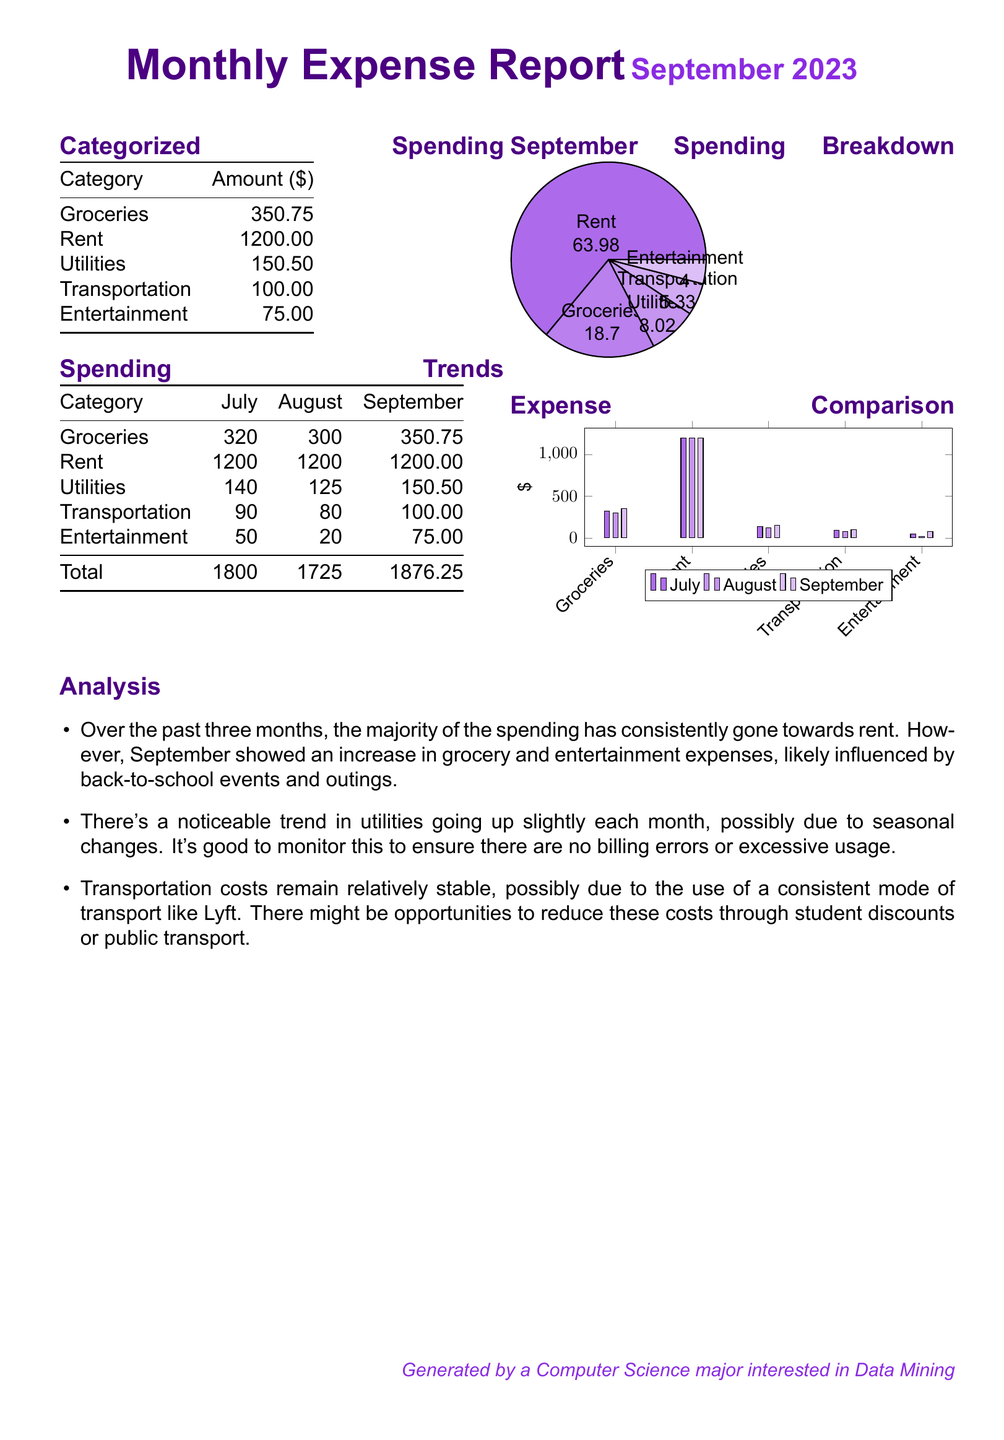What is the total amount spent in September? The total amount spent in September is found in the spending trends section, where the total is listed as $1876.25.
Answer: $1876.25 What category has the highest expenditure in September? The highest expenditure category in September is identified in the categorized spending section, where rent is shown to be $1200.00.
Answer: Rent What was the utilities expense in August? The utilities expense for August is found in the spending trends table, which shows $125.
Answer: $125 By how much did entertainment expenses increase from August to September? To find the increase, subtract the August entertainment expense ($20) from the September amount ($75), resulting in an increase of $55.
Answer: $55 What percentage of total spending in September is allocated to groceries? The spending breakdown shows groceries amounting to $350.75, which is calculated as (350.75 / 1876.25) * 100, resulting in approximately 18.7%.
Answer: 18.7% Which category showed an increase in expense every month from July to September? Examining the spending trends, utilities is the only category that shows a consistent increase from $140 in July to $150.50 in September.
Answer: Utilities What is the total amount spent on entertainment over the three months? The total for entertainment is the sum of $50 (July) + $20 (August) + $75 (September), which equals $145.
Answer: $145 How did transportation costs change from July to September? The transportation costs are $90 in July, $80 in August, and $100 in September, indicating a fluctuation with an increase in September.
Answer: Increased What is the color used for the September spending pie chart? The pie chart uses different shades of secondary color, which are identified as secondary!70, secondary!60, secondary!50, secondary!40, and secondary!30.
Answer: Secondary colors 